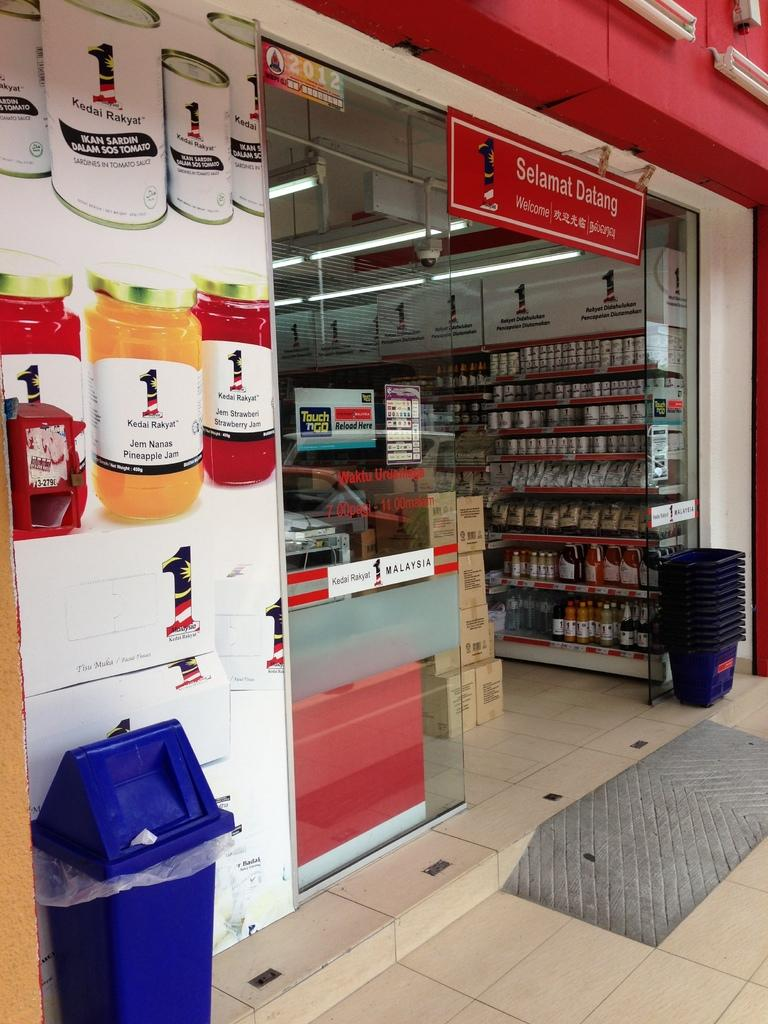<image>
Provide a brief description of the given image. The entrance of a store that is called Selamat Datang 